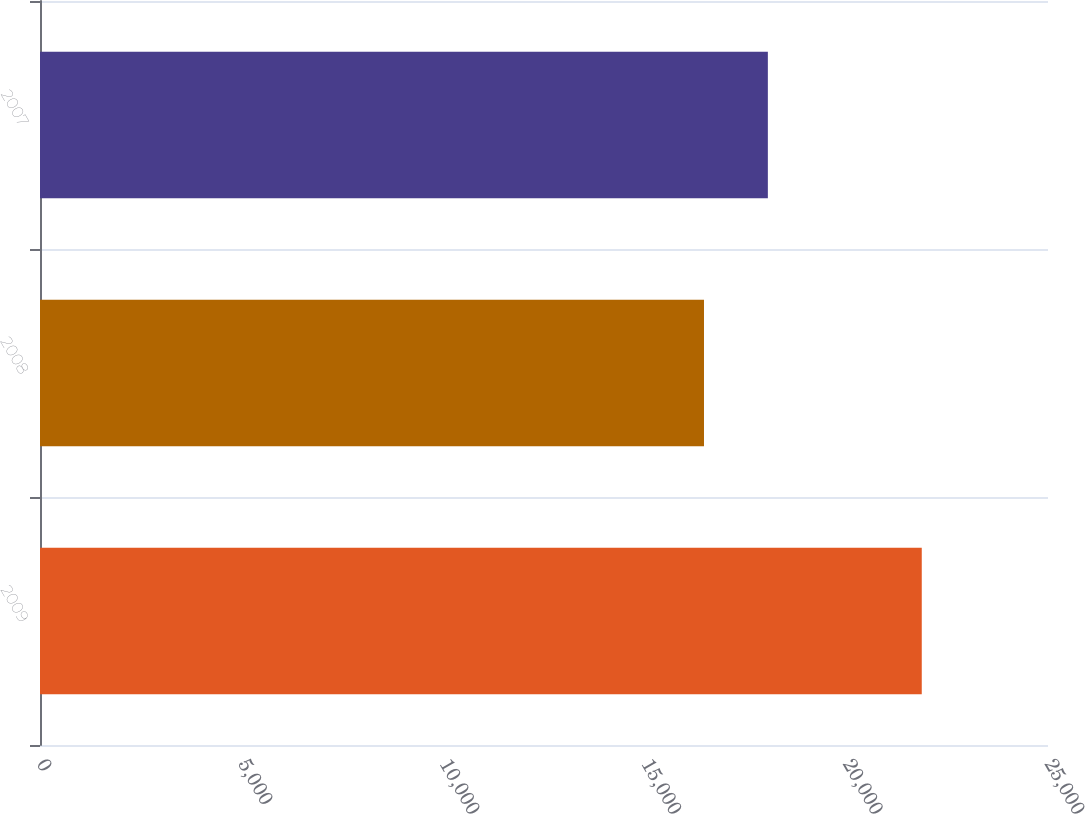<chart> <loc_0><loc_0><loc_500><loc_500><bar_chart><fcel>2009<fcel>2008<fcel>2007<nl><fcel>21869<fcel>16468<fcel>18052<nl></chart> 